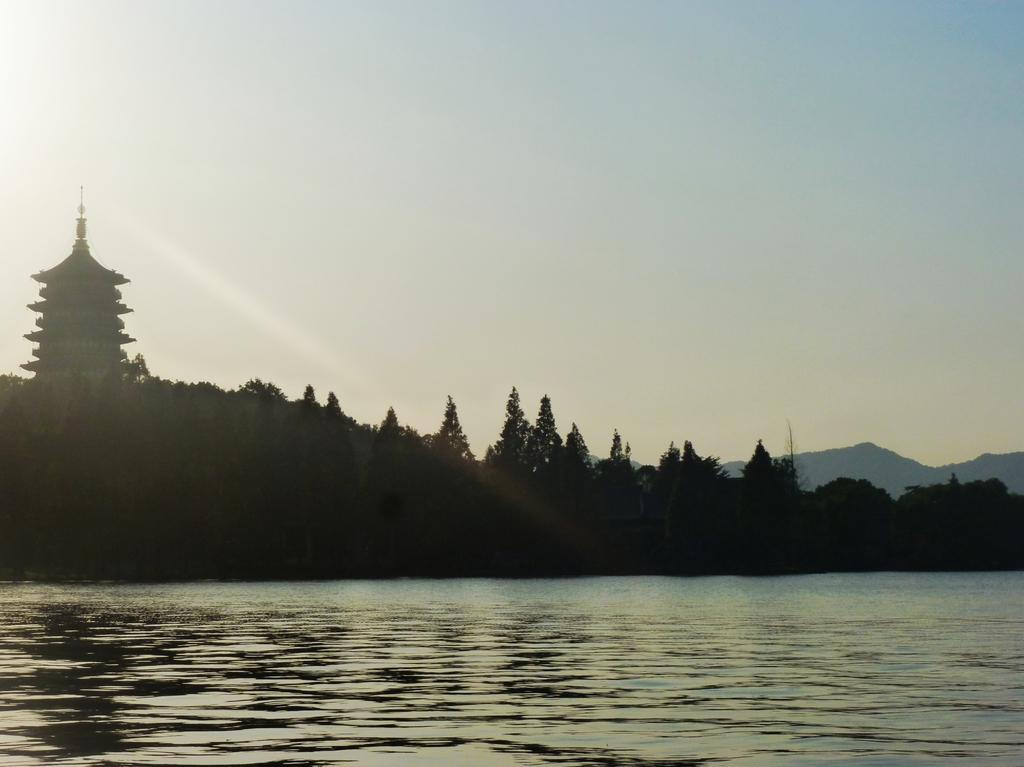What type of natural feature is at the bottom of the image? There is a river at the bottom of the image. What can be seen in the background of the image? There are trees and mountains in the background of the image. What is visible at the top of the image? The sky is visible at the top of the image. Can you tell me how many creatures are swimming in the river in the image? There is no creature visible in the river in the image. What type of snail can be seen crawling on the mountains in the image? There are no snails present in the image, and the mountains are in the background, not close enough for a snail to be visible. 